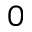Convert formula to latex. <formula><loc_0><loc_0><loc_500><loc_500>0</formula> 